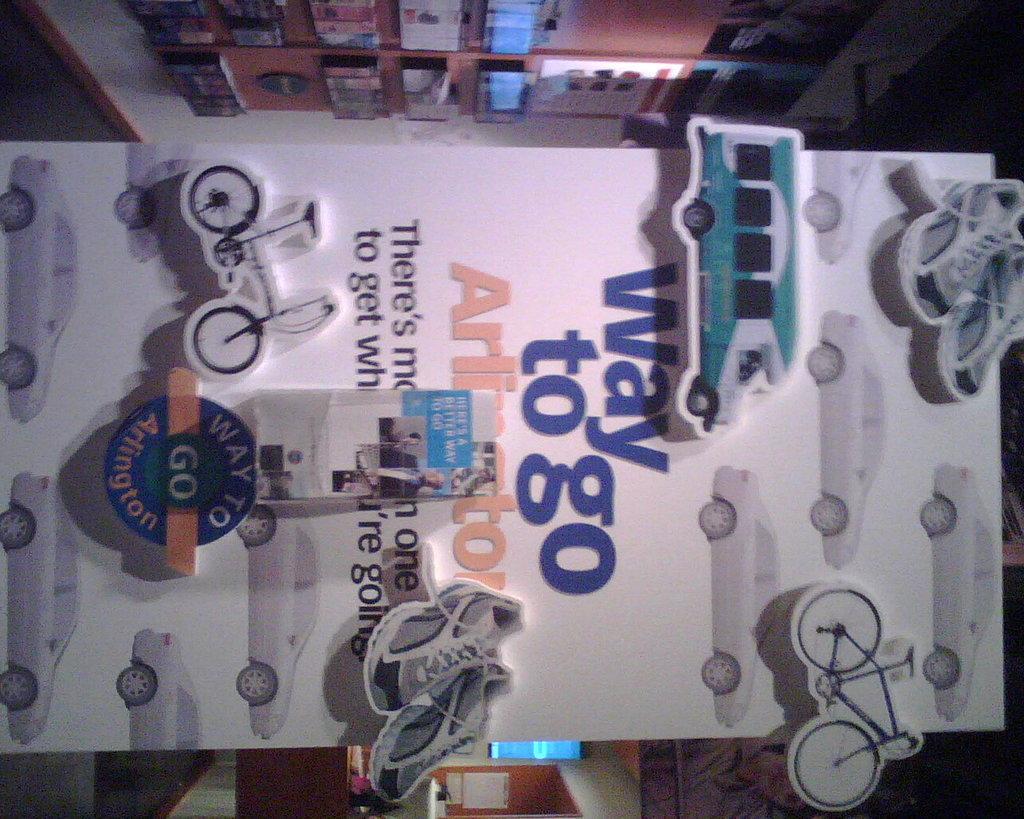In one or two sentences, can you explain what this image depicts? This picture shows the inner view of a room. There is one board decorated with some paper toys and some text on it. So many different kinds of objects attached to the wall, one banner, some objects are on the surface and some objects are on the table. 